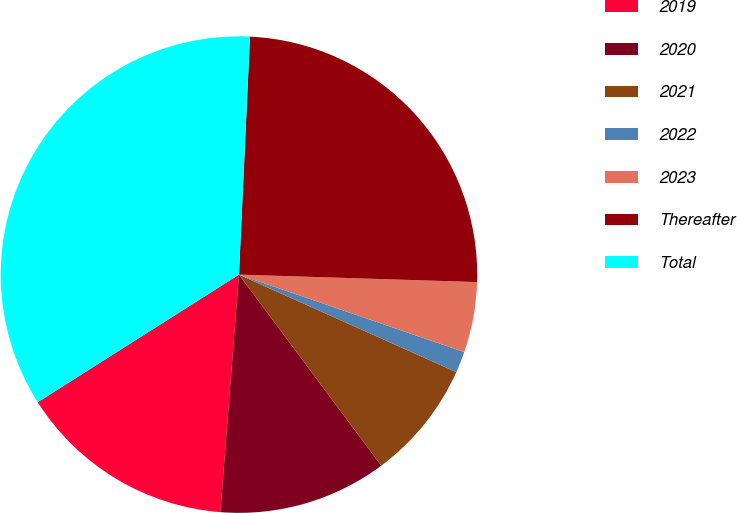Convert chart to OTSL. <chart><loc_0><loc_0><loc_500><loc_500><pie_chart><fcel>2019<fcel>2020<fcel>2021<fcel>2022<fcel>2023<fcel>Thereafter<fcel>Total<nl><fcel>14.76%<fcel>11.43%<fcel>8.1%<fcel>1.44%<fcel>4.77%<fcel>24.76%<fcel>34.73%<nl></chart> 